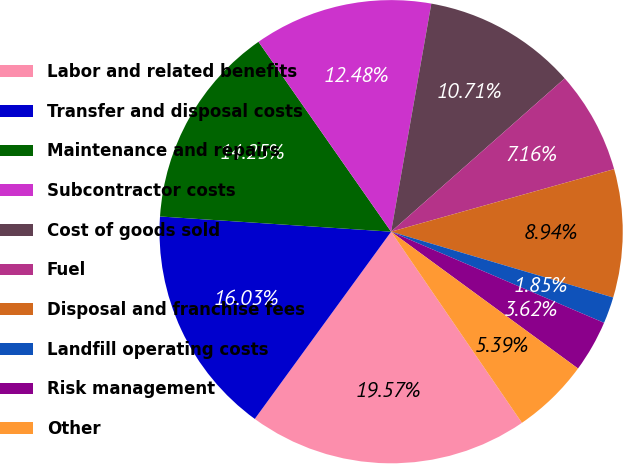<chart> <loc_0><loc_0><loc_500><loc_500><pie_chart><fcel>Labor and related benefits<fcel>Transfer and disposal costs<fcel>Maintenance and repairs<fcel>Subcontractor costs<fcel>Cost of goods sold<fcel>Fuel<fcel>Disposal and franchise fees<fcel>Landfill operating costs<fcel>Risk management<fcel>Other<nl><fcel>19.57%<fcel>16.03%<fcel>14.25%<fcel>12.48%<fcel>10.71%<fcel>7.16%<fcel>8.94%<fcel>1.85%<fcel>3.62%<fcel>5.39%<nl></chart> 